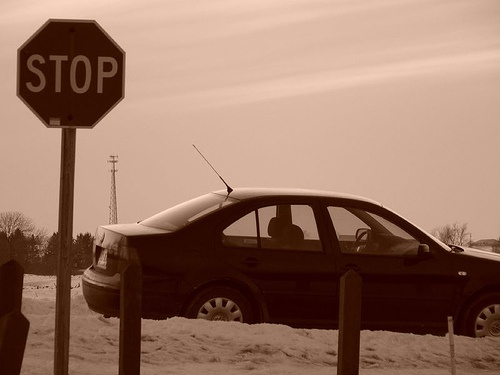Describe the objects in this image and their specific colors. I can see car in tan, black, maroon, and gray tones and stop sign in tan, maroon, and brown tones in this image. 